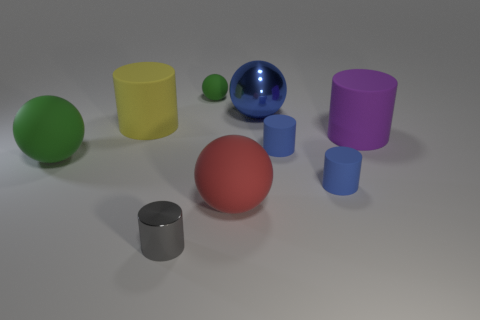Subtract all shiny cylinders. How many cylinders are left? 4 Subtract all cyan cylinders. Subtract all yellow cubes. How many cylinders are left? 5 Add 1 small cyan blocks. How many objects exist? 10 Subtract all cylinders. How many objects are left? 4 Subtract 0 blue cubes. How many objects are left? 9 Subtract all metallic cylinders. Subtract all yellow matte cylinders. How many objects are left? 7 Add 4 yellow matte cylinders. How many yellow matte cylinders are left? 5 Add 2 tiny objects. How many tiny objects exist? 6 